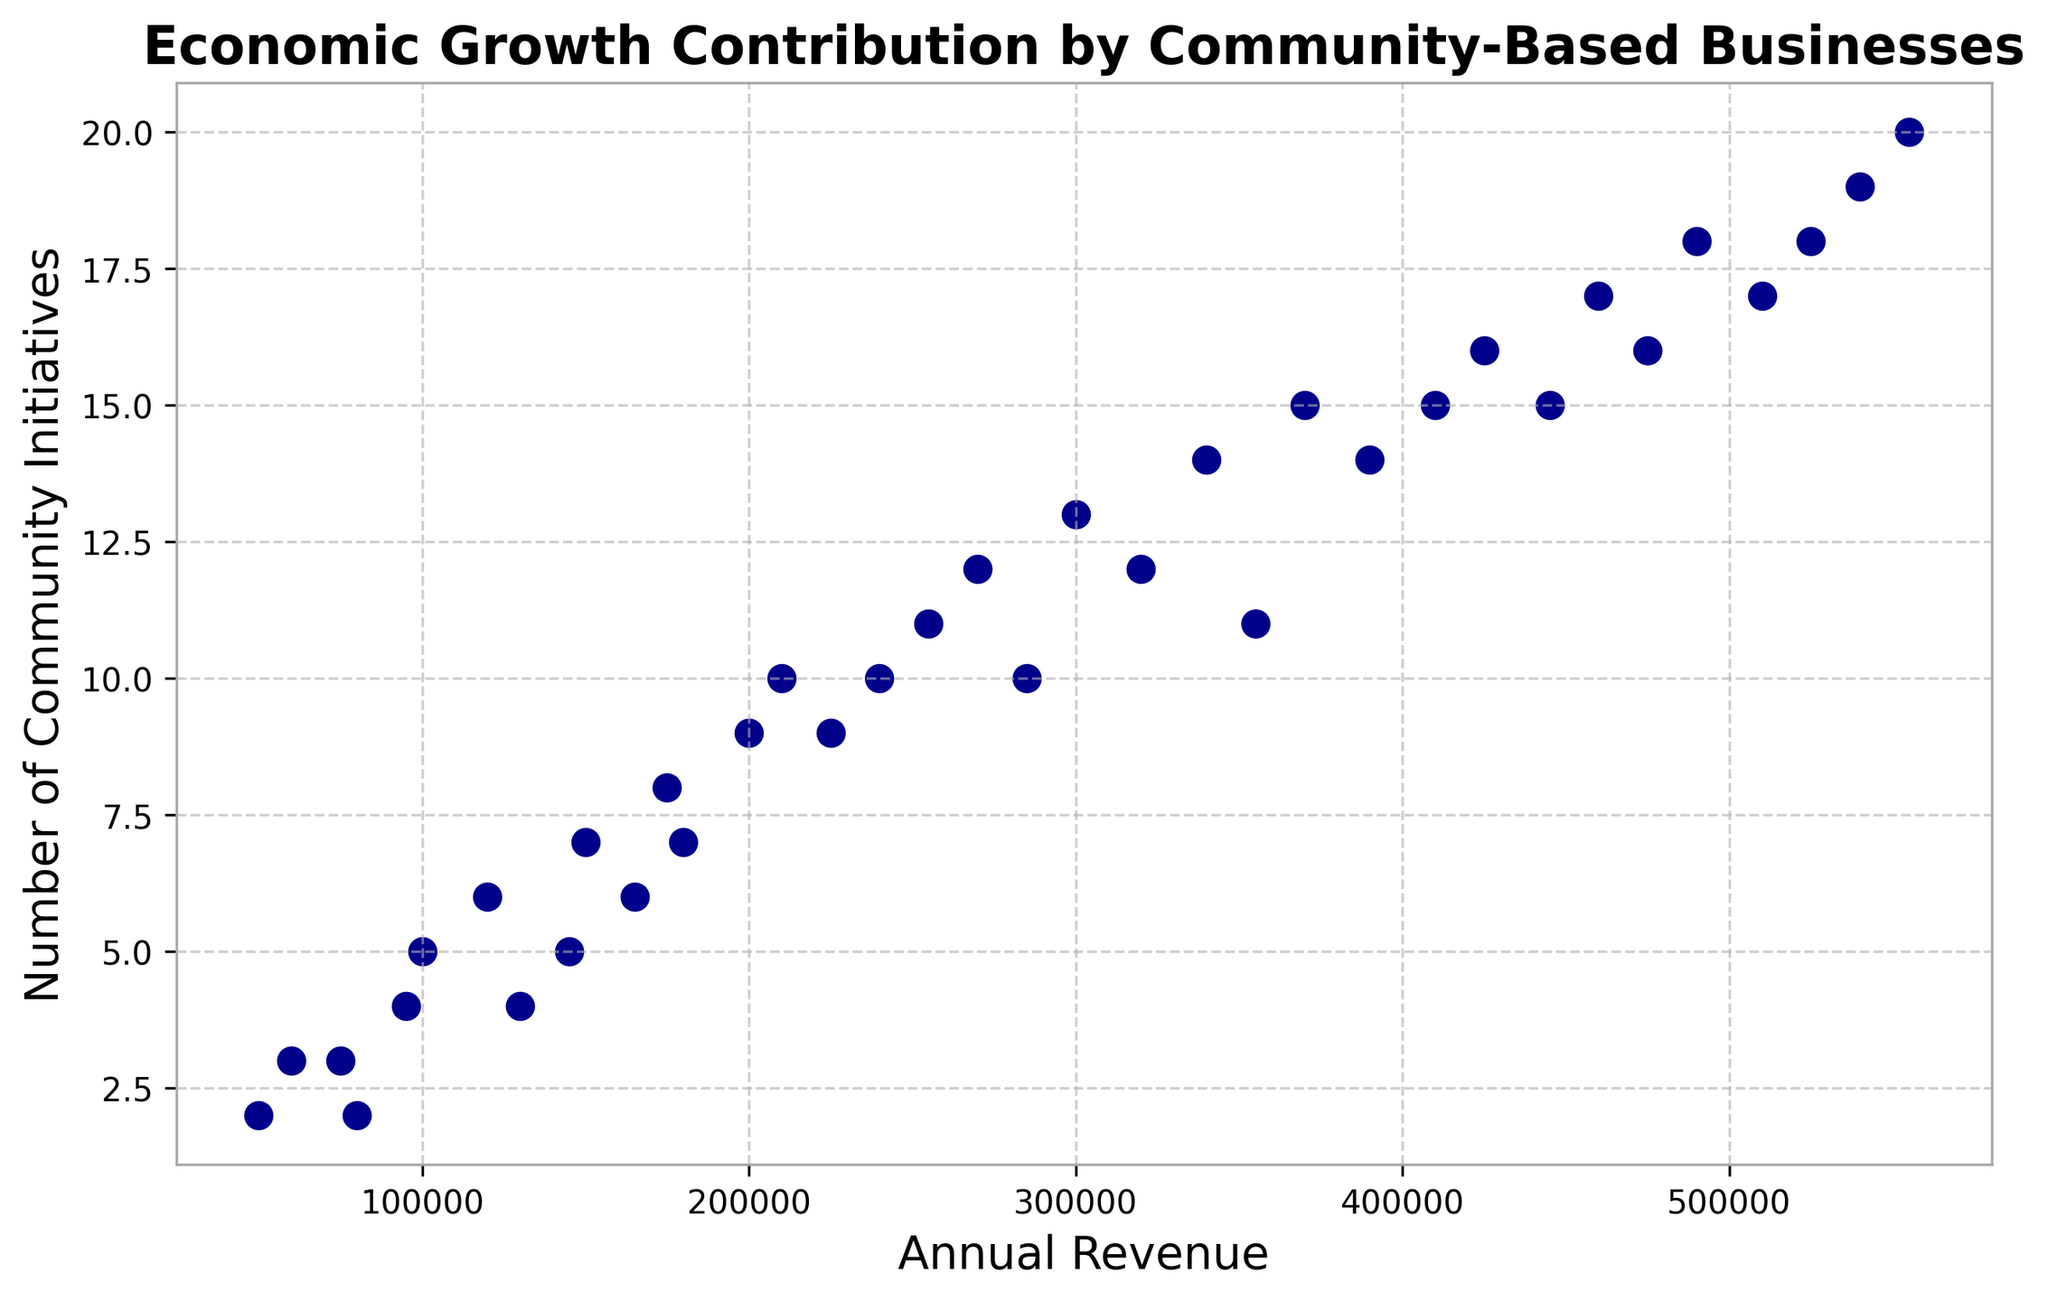What's the annual revenue for the business contributing to the highest number of community initiatives? The business that contributes the highest number of community initiatives has 20 initiatives. According to the scatter plot, the annual revenue corresponding to this is $555,000.
Answer: $555,000 Which business has more community initiatives, the one with $150,000 revenue or the one with $270,000 revenue? The business with $150,000 revenue has 7 community initiatives, and the business with $270,000 revenue has 12 initiatives. Comparing these, the business with $270,000 revenue has more community initiatives.
Answer: The one with $270,000 revenue What's the difference in community initiatives between the businesses with the lowest and highest revenue? The business with the lowest revenue ($50,000) has 2 community initiatives, and the one with the highest revenue ($555,000) has 20 initiatives. The difference in community initiatives is 20 - 2 = 18.
Answer: 18 What's the average number of community initiatives for businesses with revenues below $200,000? The revenues below $200,000 are $50,000, $60,000, $75,000, $80,000, $95,000, $100,000, $120,000, $130,000, $145,000, $150,000, $165,000, $175,000, and $180,000. The respective community initiatives are 2, 3, 3, 2, 4, 5, 6, 4, 5, 7, 6, 8, and 7. The total number of initiatives is 62, and there are 13 businesses, so the average is 62/13 = 4.77.
Answer: 4.77 Is there a positive correlation between annual revenue and the number of community initiatives? Observing the scatter plot, it shows that as the annual revenue increases, the number of community initiatives also tends to increase. This indicates a positive correlation.
Answer: Yes Which business contributed fewer initiatives, the one with $120,000 annual revenue or the one with $130,000 annual revenue? The business with $120,000 annual revenue has 6 community initiatives, and the one with $130,000 annual revenue has 4 initiatives. Therefore, the business with $130,000 revenue contributed fewer initiatives.
Answer: The one with $130,000 revenue What is the median number of community initiatives for businesses with revenues between $200,000 and $300,000? The revenues between $200,000 and $300,000 are $200,000, $210,000, $225,000, $240,000, $255,000, $270,000, $285,000, and $300,000. The respective initiatives are 9, 10, 9, 10, 11, 12, 10, and 13. Sorting these values gives: 9, 9, 10, 10, 10, 11, 12, 13. The median is the average of the 4th and 5th values: (10 + 10) / 2 = 10.
Answer: 10 Are there any businesses that contribute the same number of community initiatives but have different annual revenues? Yes, some examples include businesses with annual revenues of $210,000 and $240,000, both contributing 10 initiatives, and businesses with annual revenues of $225,000 and $285,000, both also contributing 10 initiatives.
Answer: Yes What's the range of annual revenues shown in the figure? The lowest annual revenue is $50,000 and the highest is $555,000. Therefore, the range is $555,000 - $50,000 = $505,000.
Answer: $505,000 What is the typical number of community initiatives for a business with an annual revenue of around $350,000? For revenues close to $350,000, such as $340,000, $355,000, $370,000, the respective initiatives are 14, 11, and 15. Observing these values, the typical number of community initiatives is approximately between 11 and 15.
Answer: Between 11 and 15 